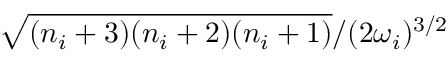<formula> <loc_0><loc_0><loc_500><loc_500>\sqrt { { ( n _ { i } + 3 ) ( n _ { i } + 2 ) ( n _ { i } + 1 ) } } / { ( 2 \omega _ { i } ) ^ { 3 / 2 } }</formula> 